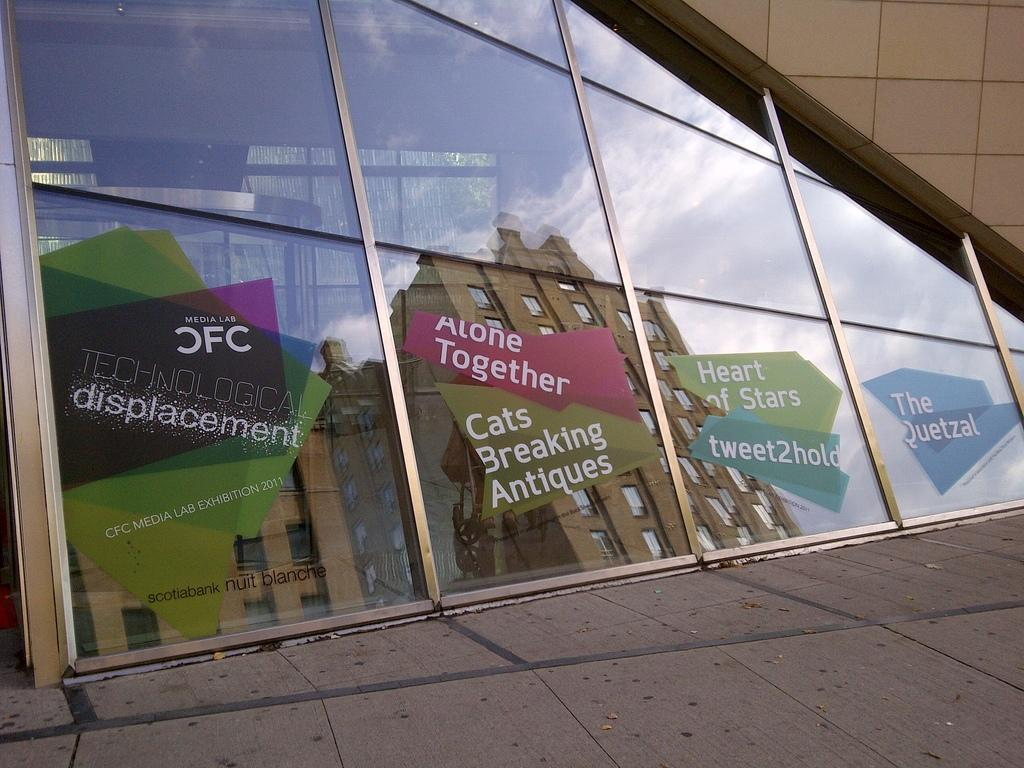What object is present in the image that can hold a liquid? There is a glass in the image. What is written on the glass? Something is written on the glass. What can be seen on the other side of the glass? The reflection of buildings and the sky is visible on the glass. What is the background of the image? There is a wall in the image. What game is being played on the glass in the image? There is no game being played on the glass in the image. Who is the achiever mentioned on the glass? There is no mention of an achiever on the glass in the image. 